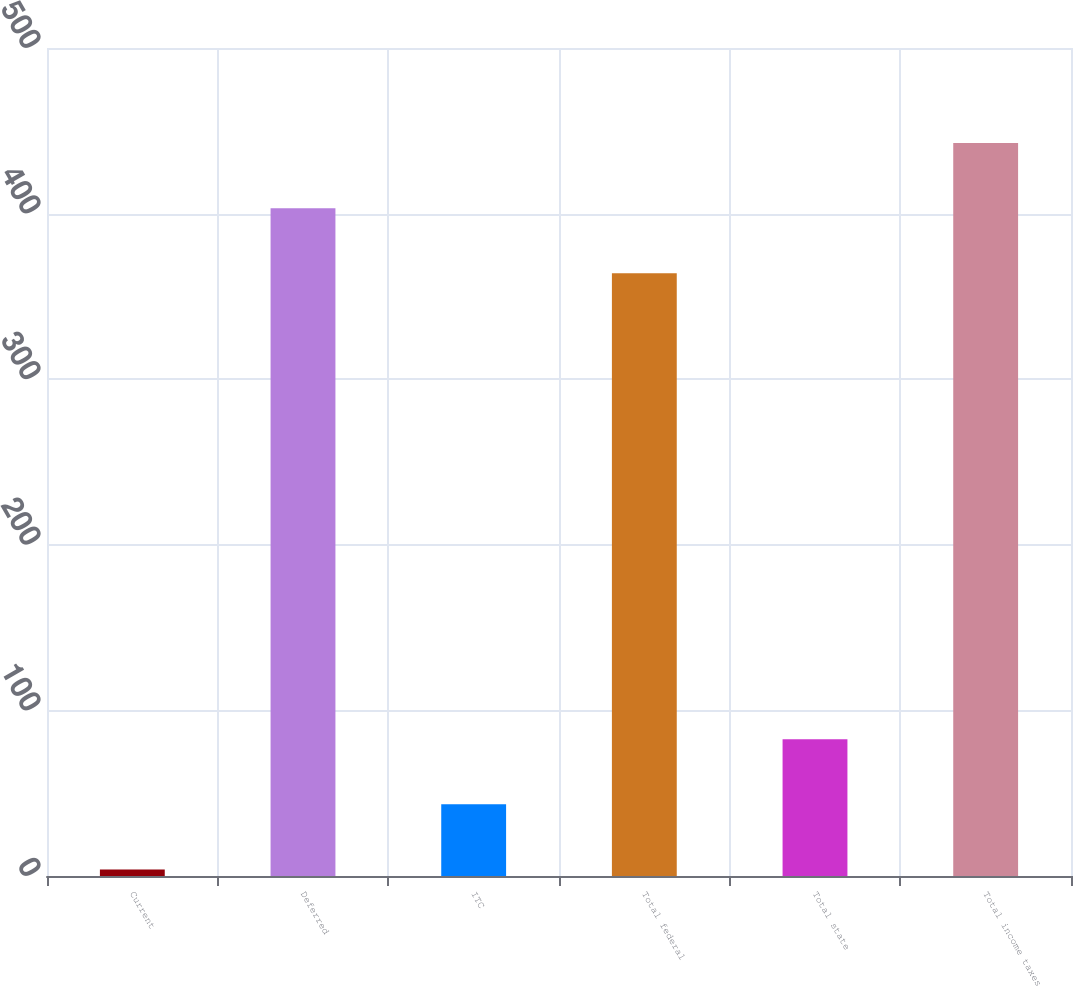Convert chart to OTSL. <chart><loc_0><loc_0><loc_500><loc_500><bar_chart><fcel>Current<fcel>Deferred<fcel>ITC<fcel>Total federal<fcel>Total state<fcel>Total income taxes<nl><fcel>4<fcel>403.3<fcel>43.3<fcel>364<fcel>82.6<fcel>442.6<nl></chart> 